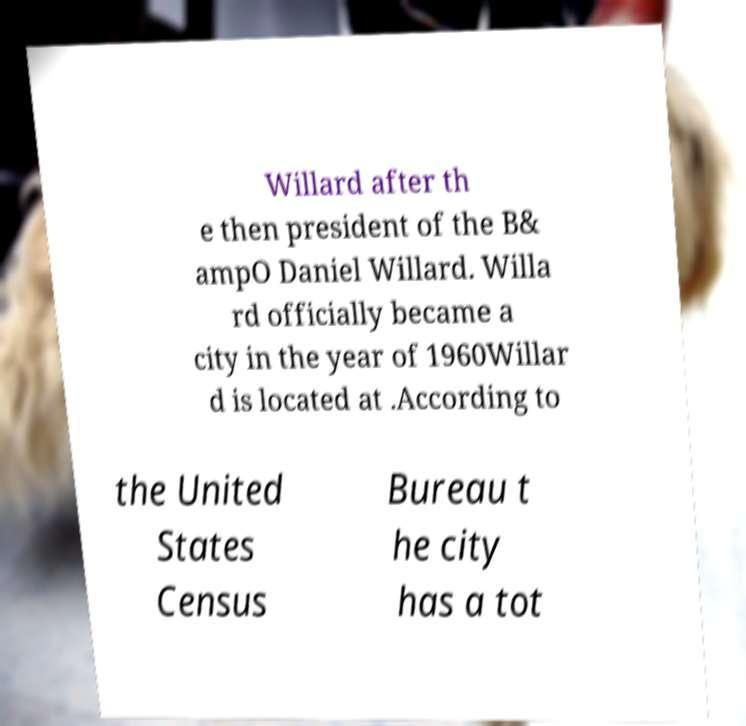What messages or text are displayed in this image? I need them in a readable, typed format. Willard after th e then president of the B& ampO Daniel Willard. Willa rd officially became a city in the year of 1960Willar d is located at .According to the United States Census Bureau t he city has a tot 